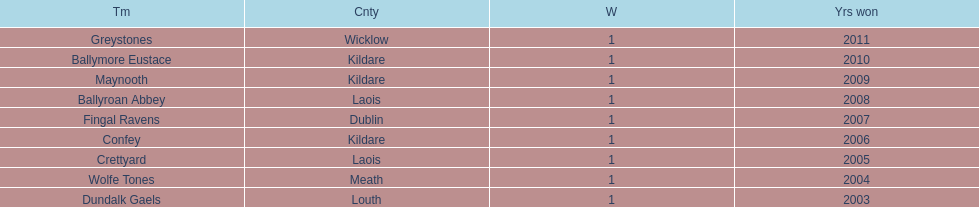What is the total count of wins for every team? 1. 